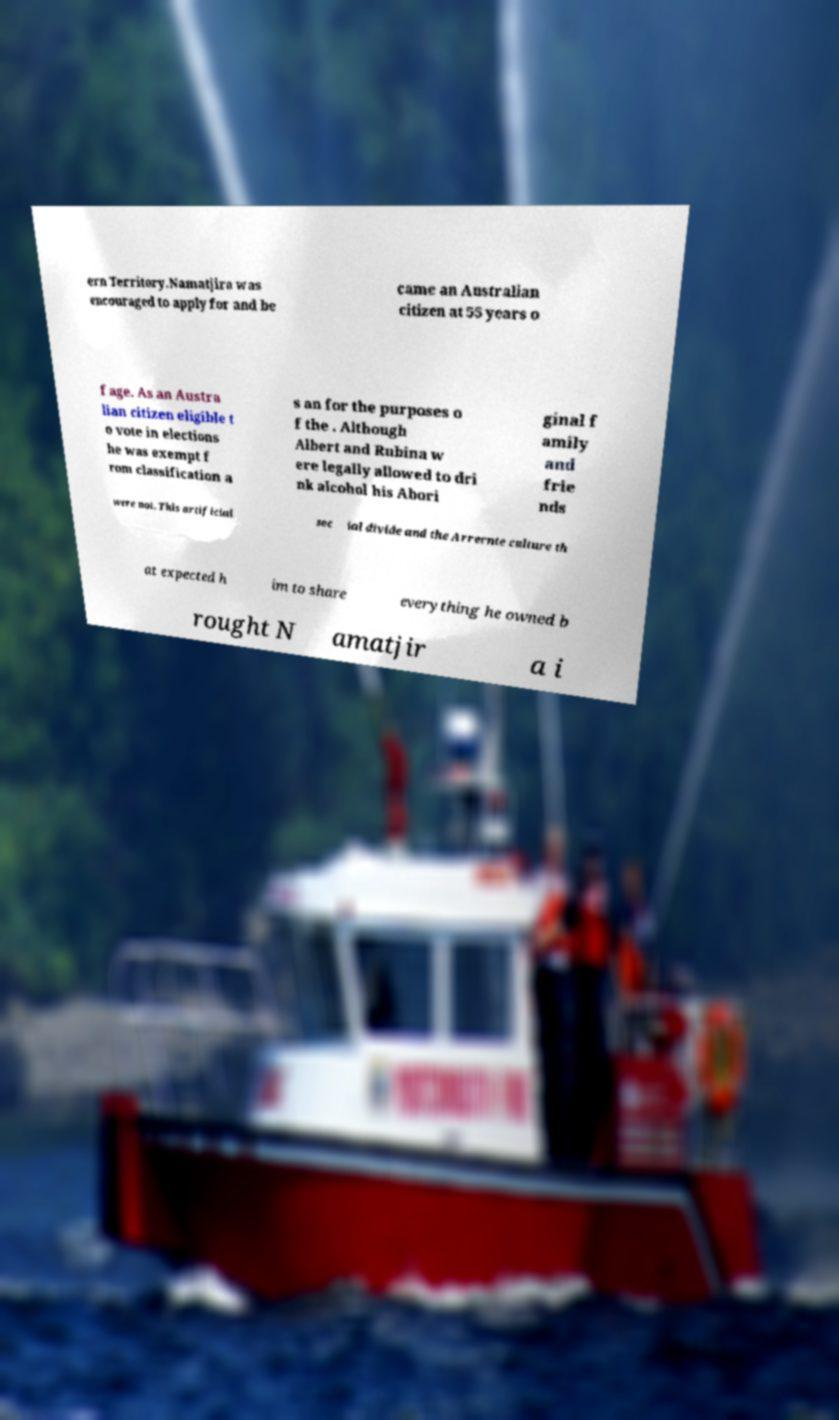Can you read and provide the text displayed in the image?This photo seems to have some interesting text. Can you extract and type it out for me? ern Territory.Namatjira was encouraged to apply for and be came an Australian citizen at 55 years o f age. As an Austra lian citizen eligible t o vote in elections he was exempt f rom classification a s an for the purposes o f the . Although Albert and Rubina w ere legally allowed to dri nk alcohol his Abori ginal f amily and frie nds were not. This artificial soc ial divide and the Arrernte culture th at expected h im to share everything he owned b rought N amatjir a i 